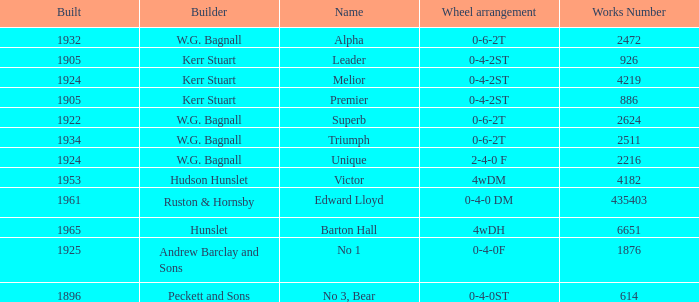What is the work number for Victor? 4182.0. 